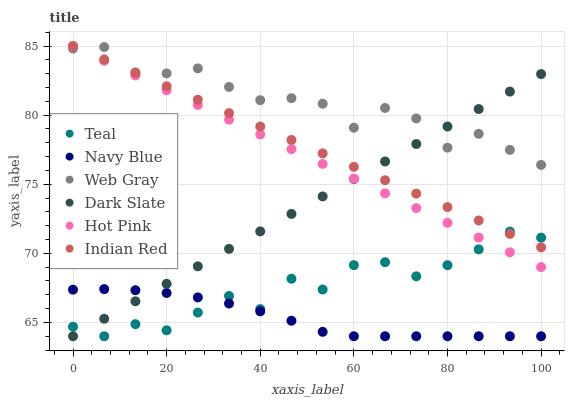Does Navy Blue have the minimum area under the curve?
Answer yes or no. Yes. Does Web Gray have the maximum area under the curve?
Answer yes or no. Yes. Does Teal have the minimum area under the curve?
Answer yes or no. No. Does Teal have the maximum area under the curve?
Answer yes or no. No. Is Hot Pink the smoothest?
Answer yes or no. Yes. Is Teal the roughest?
Answer yes or no. Yes. Is Navy Blue the smoothest?
Answer yes or no. No. Is Navy Blue the roughest?
Answer yes or no. No. Does Teal have the lowest value?
Answer yes or no. Yes. Does Hot Pink have the lowest value?
Answer yes or no. No. Does Indian Red have the highest value?
Answer yes or no. Yes. Does Teal have the highest value?
Answer yes or no. No. Is Navy Blue less than Web Gray?
Answer yes or no. Yes. Is Web Gray greater than Teal?
Answer yes or no. Yes. Does Web Gray intersect Dark Slate?
Answer yes or no. Yes. Is Web Gray less than Dark Slate?
Answer yes or no. No. Is Web Gray greater than Dark Slate?
Answer yes or no. No. Does Navy Blue intersect Web Gray?
Answer yes or no. No. 